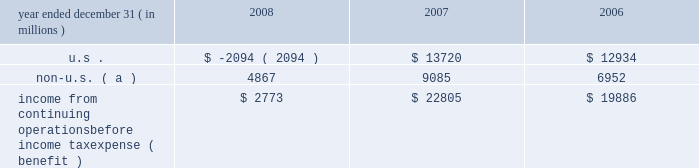Jpmorgan chase & co .
/ 2008 annual report 211 jpmorgan chase is subject to ongoing tax examinations by the tax authorities of the various jurisdictions in which it operates , including u.s .
Federal and state and non-u.s .
Jurisdictions .
The firm 2019s consoli- dated federal income tax returns are presently under examination by the internal revenue service ( 201cirs 201d ) for the years 2003 , 2004 and 2005 .
The consolidated federal income tax returns of bank one corporation , which merged with and into jpmorgan chase on july 1 , 2004 , are under examination for the years 2000 through 2003 , and for the period january 1 , 2004 , through july 1 , 2004 .
The consolidat- ed federal income tax returns of bear stearns for the years ended november 30 , 2003 , 2004 and 2005 , are also under examination .
All three examinations are expected to conclude in 2009 .
The irs audits of the consolidated federal income tax returns of jpmorgan chase for the years 2006 and 2007 , and for bear stearns for the years ended november 30 , 2006 and 2007 , are expected to commence in 2009 .
Administrative appeals are pending with the irs relating to prior examination periods .
For 2002 and prior years , refund claims relating to income and credit adjustments , and to tax attribute carry- backs , for jpmorgan chase and its predecessor entities , including bank one , have been filed .
Amended returns to reflect refund claims primarily attributable to net operating losses and tax credit carry- backs will be filed for the final bear stearns federal consolidated tax return for the period december 1 , 2007 , through may 30 , 2008 , and for prior years .
The table presents the u.s .
And non-u.s .
Components of income from continuing operations before income tax expense ( benefit ) . .
Non-u.s. ( a ) 4867 9085 6952 income from continuing operations before income tax expense ( benefit ) $ 2773 $ 22805 $ 19886 ( a ) for purposes of this table , non-u.s .
Income is defined as income generated from operations located outside the u.s .
Note 29 2013 restrictions on cash and intercom- pany funds transfers the business of jpmorgan chase bank , national association ( 201cjpmorgan chase bank , n.a . 201d ) is subject to examination and regula- tion by the office of the comptroller of the currency ( 201cocc 201d ) .
The bank is a member of the u.s .
Federal reserve system , and its deposits are insured by the fdic as discussed in note 20 on page 202 of this annual report .
The board of governors of the federal reserve system ( the 201cfederal reserve 201d ) requires depository institutions to maintain cash reserves with a federal reserve bank .
The average amount of reserve bal- ances deposited by the firm 2019s bank subsidiaries with various federal reserve banks was approximately $ 1.6 billion in 2008 and 2007 .
Restrictions imposed by u.s .
Federal law prohibit jpmorgan chase and certain of its affiliates from borrowing from banking subsidiaries unless the loans are secured in specified amounts .
Such secured loans to the firm or to other affiliates are generally limited to 10% ( 10 % ) of the banking subsidiary 2019s total capital , as determined by the risk- based capital guidelines ; the aggregate amount of all such loans is limited to 20% ( 20 % ) of the banking subsidiary 2019s total capital .
The principal sources of jpmorgan chase 2019s income ( on a parent com- pany 2013only basis ) are dividends and interest from jpmorgan chase bank , n.a. , and the other banking and nonbanking subsidiaries of jpmorgan chase .
In addition to dividend restrictions set forth in statutes and regulations , the federal reserve , the occ and the fdic have authority under the financial institutions supervisory act to pro- hibit or to limit the payment of dividends by the banking organizations they supervise , including jpmorgan chase and its subsidiaries that are banks or bank holding companies , if , in the banking regulator 2019s opin- ion , payment of a dividend would constitute an unsafe or unsound practice in light of the financial condition of the banking organization .
At january 1 , 2009 and 2008 , jpmorgan chase 2019s banking sub- sidiaries could pay , in the aggregate , $ 17.0 billion and $ 16.2 billion , respectively , in dividends to their respective bank holding companies without the prior approval of their relevant banking regulators .
The capacity to pay dividends in 2009 will be supplemented by the bank- ing subsidiaries 2019 earnings during the year .
In compliance with rules and regulations established by u.s .
And non-u.s .
Regulators , as of december 31 , 2008 and 2007 , cash in the amount of $ 20.8 billion and $ 16.0 billion , respectively , and securities with a fair value of $ 12.1 billion and $ 3.4 billion , respectively , were segregated in special bank accounts for the benefit of securities and futures brokerage customers. .
Without foreign operations in 2008 , what would the pre-tax income from continuing operations be? 
Computations: ((2773 - 4867) * 1000000)
Answer: -2094000000.0. 